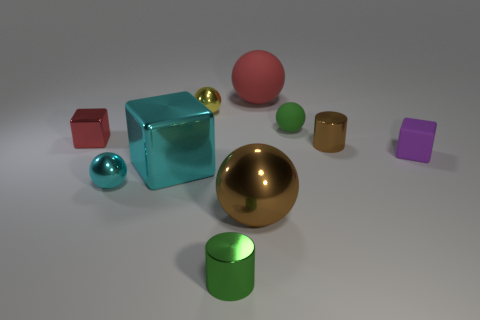Subtract all small purple cubes. How many cubes are left? 2 Subtract all purple cubes. How many cubes are left? 2 Subtract 1 spheres. How many spheres are left? 4 Subtract all cylinders. How many objects are left? 8 Subtract all brown balls. Subtract all red cylinders. How many balls are left? 4 Add 7 blocks. How many blocks are left? 10 Add 7 large things. How many large things exist? 10 Subtract 1 green spheres. How many objects are left? 9 Subtract all blue cubes. Subtract all large cyan cubes. How many objects are left? 9 